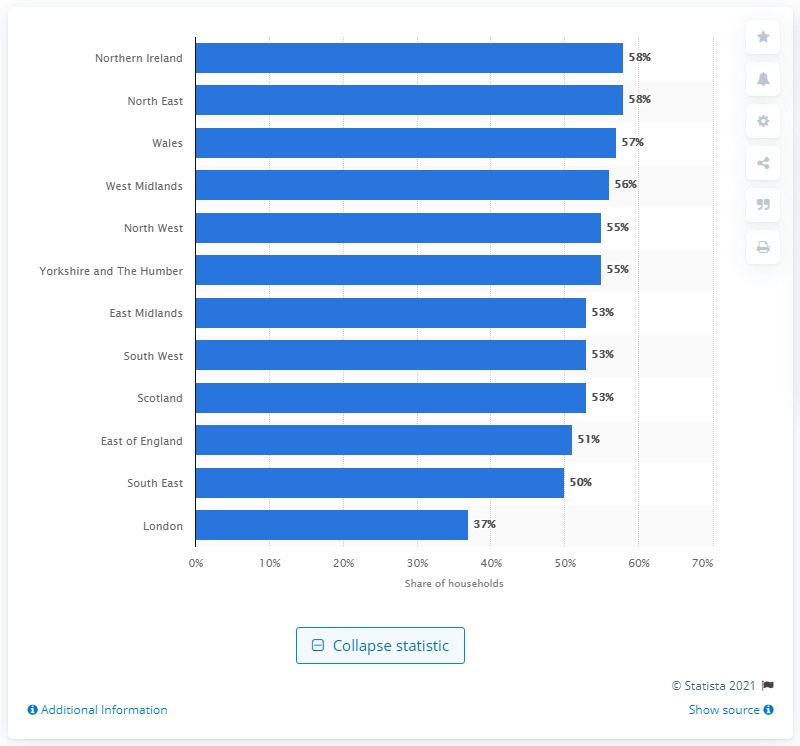Mention a couple of crucial points in this snapshot. In the United Kingdom, London was the only region where less than half of the population received benefits. 